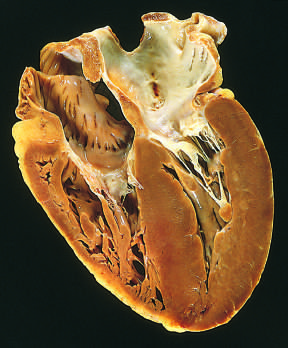s plaque rupture without on the lower right in this apical four-chamber view of the heart?
Answer the question using a single word or phrase. No 